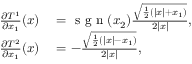<formula> <loc_0><loc_0><loc_500><loc_500>\begin{array} { r l } { \frac { \partial T ^ { 1 } } { \partial x _ { 1 } } ( x ) } & = s g n ( x _ { 2 } ) \frac { \sqrt { \frac { 1 } { 2 } \left ( | x | + x _ { 1 } \right ) } } { 2 | x | } , } \\ { \frac { \partial T ^ { 2 } } { \partial x _ { 1 } } ( x ) } & = - \frac { \sqrt { \frac { 1 } { 2 } \left ( | x | - x _ { 1 } \right ) } } { 2 | x | } , } \end{array}</formula> 